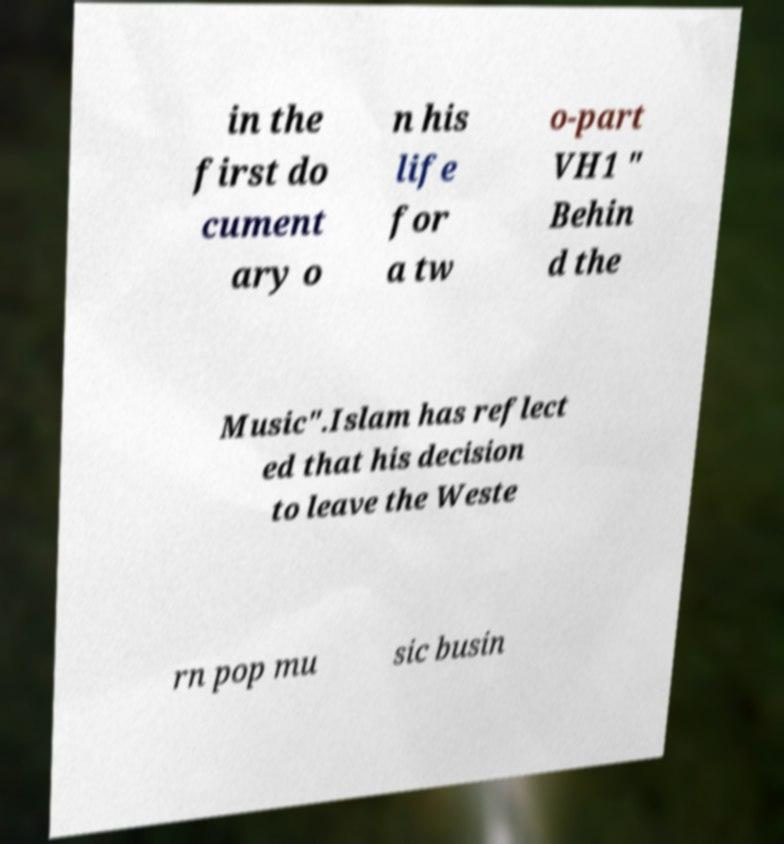Please identify and transcribe the text found in this image. in the first do cument ary o n his life for a tw o-part VH1 " Behin d the Music".Islam has reflect ed that his decision to leave the Weste rn pop mu sic busin 